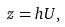<formula> <loc_0><loc_0><loc_500><loc_500>z = h U ,</formula> 